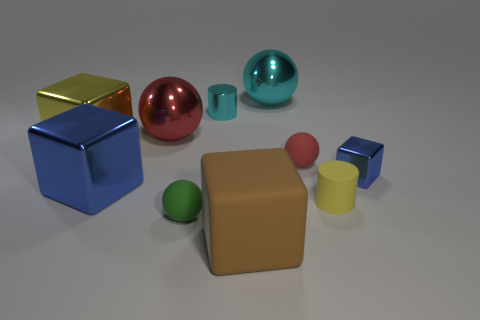Subtract 1 spheres. How many spheres are left? 3 Subtract all cubes. How many objects are left? 6 Add 5 blocks. How many blocks are left? 9 Add 2 red metal things. How many red metal things exist? 3 Subtract 0 purple spheres. How many objects are left? 10 Subtract all tiny rubber spheres. Subtract all blue objects. How many objects are left? 6 